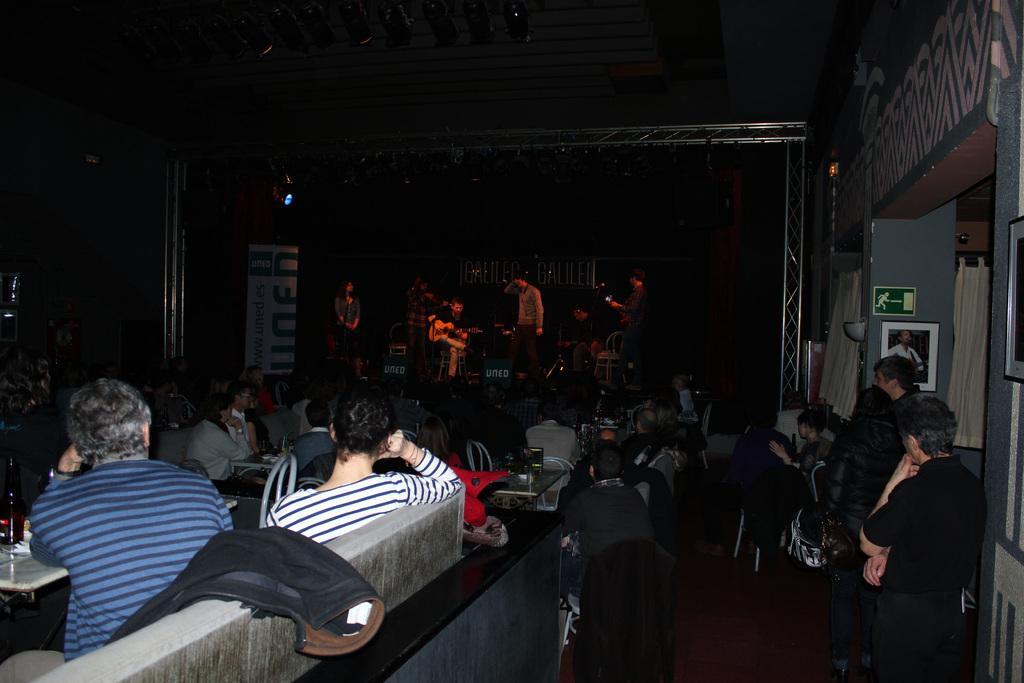In one or two sentences, can you explain what this image depicts? This image is taken indoors. In this image the background is dark. There are a few boards with text on them. A few people are sitting on the chairs and a few are standing. On the right side of the image there is a wall with a few picture frames on it and there is a pillar. There is a curtain. A few people are standing on the floor and a few are sitting on the chairs. In the middle of the image many people are sitting on the chairs and there are a few tables with many things on them. There is a jacket on the wall. 